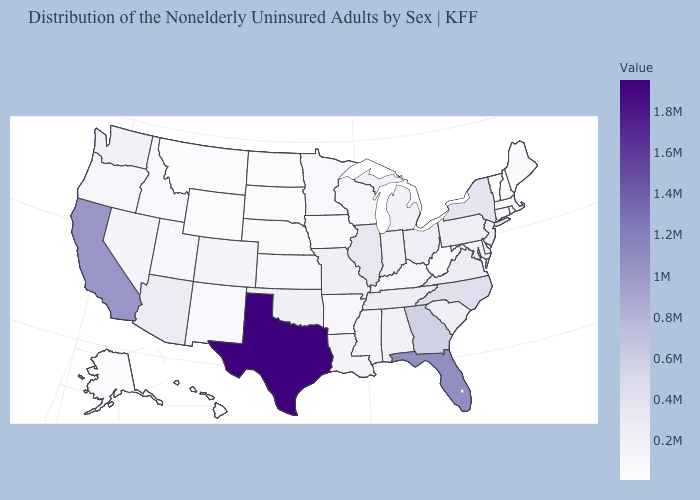Does Colorado have a lower value than Georgia?
Concise answer only. Yes. Does Kansas have the highest value in the USA?
Be succinct. No. Among the states that border Idaho , does Wyoming have the lowest value?
Concise answer only. Yes. Among the states that border Wyoming , which have the highest value?
Give a very brief answer. Colorado. Does Texas have the highest value in the USA?
Write a very short answer. Yes. Among the states that border Maryland , which have the highest value?
Give a very brief answer. Virginia. 